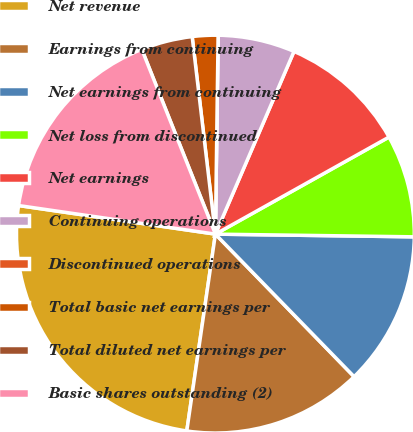<chart> <loc_0><loc_0><loc_500><loc_500><pie_chart><fcel>Net revenue<fcel>Earnings from continuing<fcel>Net earnings from continuing<fcel>Net loss from discontinued<fcel>Net earnings<fcel>Continuing operations<fcel>Discontinued operations<fcel>Total basic net earnings per<fcel>Total diluted net earnings per<fcel>Basic shares outstanding (2)<nl><fcel>25.0%<fcel>14.58%<fcel>12.5%<fcel>8.33%<fcel>10.42%<fcel>6.25%<fcel>0.0%<fcel>2.08%<fcel>4.17%<fcel>16.67%<nl></chart> 